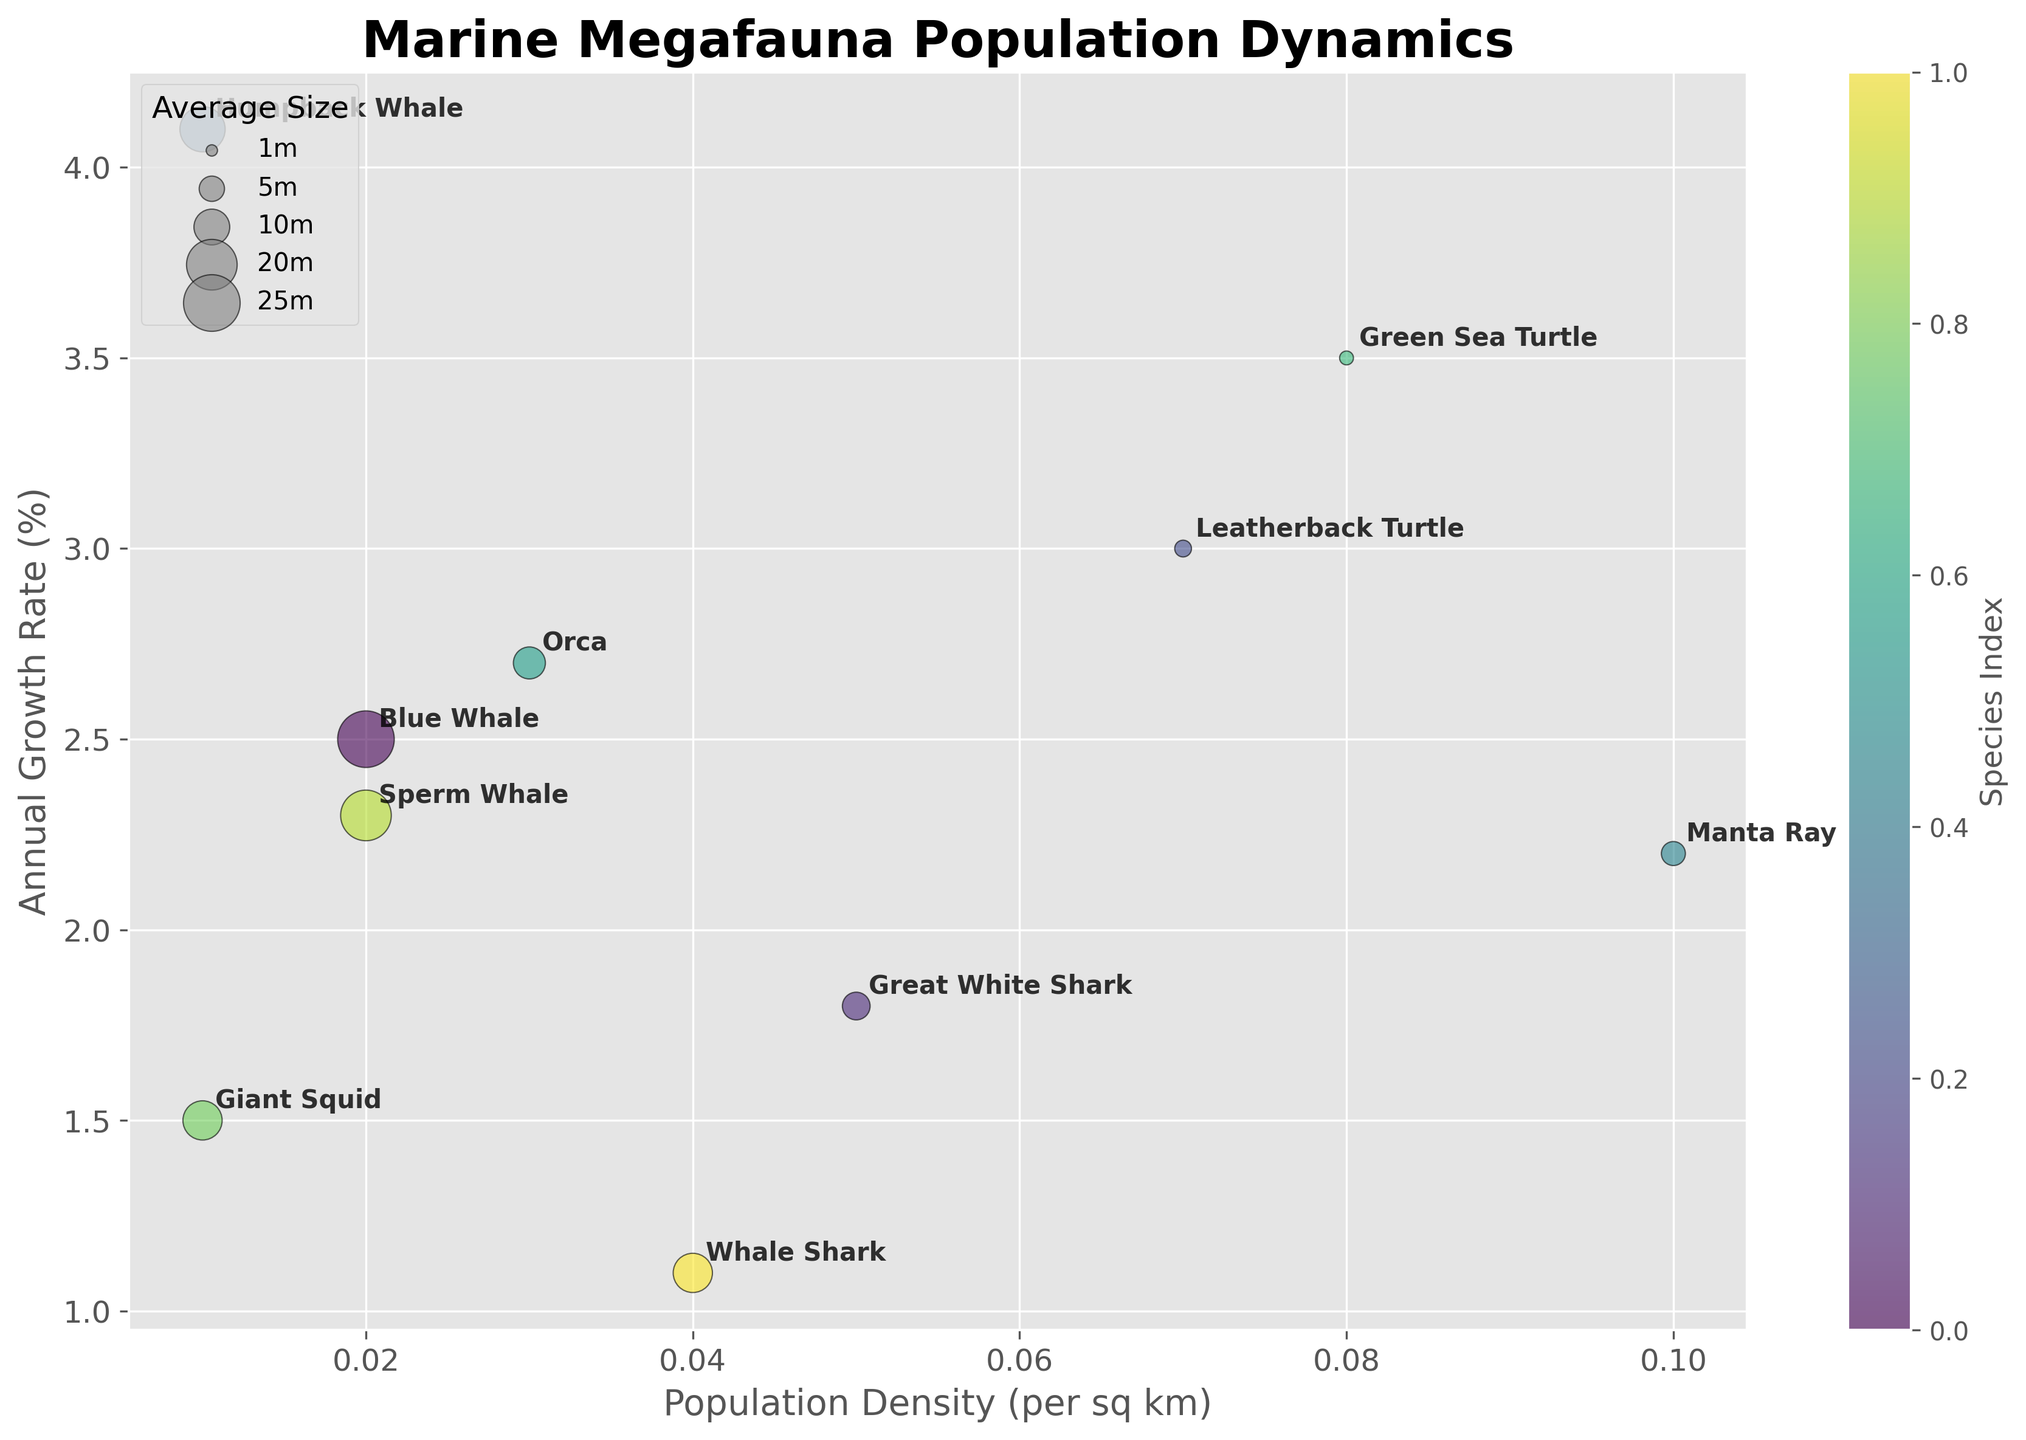What is the title of the figure? The title of a chart is usually found at the top of the figure. It provides a summary of what the chart is about. The title of this chart is "Marine Megafauna Population Dynamics".
Answer: Marine Megafauna Population Dynamics What are the labels of the X and Y axes? The X and Y axes labels are typically found alongside their respective axes. They indicate what data each axis represents. In this figure, the X axis is labeled "Population Density (per sq km)" and the Y axis is labeled "Annual Growth Rate (%)".
Answer: Population Density (per sq km), Annual Growth Rate (%) Which species has the highest population density in the presented regions? To find this, look at the bubble with the highest value on the X axis. The Manta Ray in the Coral Triangle region has the highest population density.
Answer: Manta Ray Which species is experiencing the highest annual growth rate? Look for the bubble that is the highest on the Y axis. The Humpback Whale in the Antarctic Ocean region has the highest annual growth rate.
Answer: Humpback Whale How many species have a population density greater than 0.05 per sq km? Identify bubbles to the right of the 0.05 mark on the X axis. The Great White Shark, Leatherback Turtle, Manta Ray, and Green Sea Turtle all meet this criteria, totaling four species.
Answer: 4 What's the combined average size of the Blue Whale and the Sperm Whale? The average size of the Blue Whale is 25 meters and the Sperm Whale is 20 meters. Their combined average size is (25 + 20) / 2 = 22.5 meters.
Answer: 22.5 meters Which species is represented by the smallest bubble size? The bubble size correlates with the average size of the species. The Green Sea Turtle, with an average size of 1.5 meters, has the smallest bubble.
Answer: Green Sea Turtle Does the Orca or the Whale Shark have a lower population density? Compare the X axis values for both species. The Orca (0.03 per sq km) has a higher population density than the Whale Shark (0.04 per sq km), so Orca has a lower population density.
Answer: Orca Compare the annual growth rates of the Blue Whale and the Great White Shark. Which one is growing faster? Examine the Y axis values for both species. The Blue Whale has an annual growth rate of 2.5% while the Great White Shark has 1.8%. Thus, the Blue Whale is growing faster.
Answer: Blue Whale What is the color of the bubble representing the Giant Squid? Each bubble has a color from the viridis color map. The Giant Squid's bubble, according to its position in the color continuum, appears to be greenish-yellow.
Answer: Greenish-yellow 